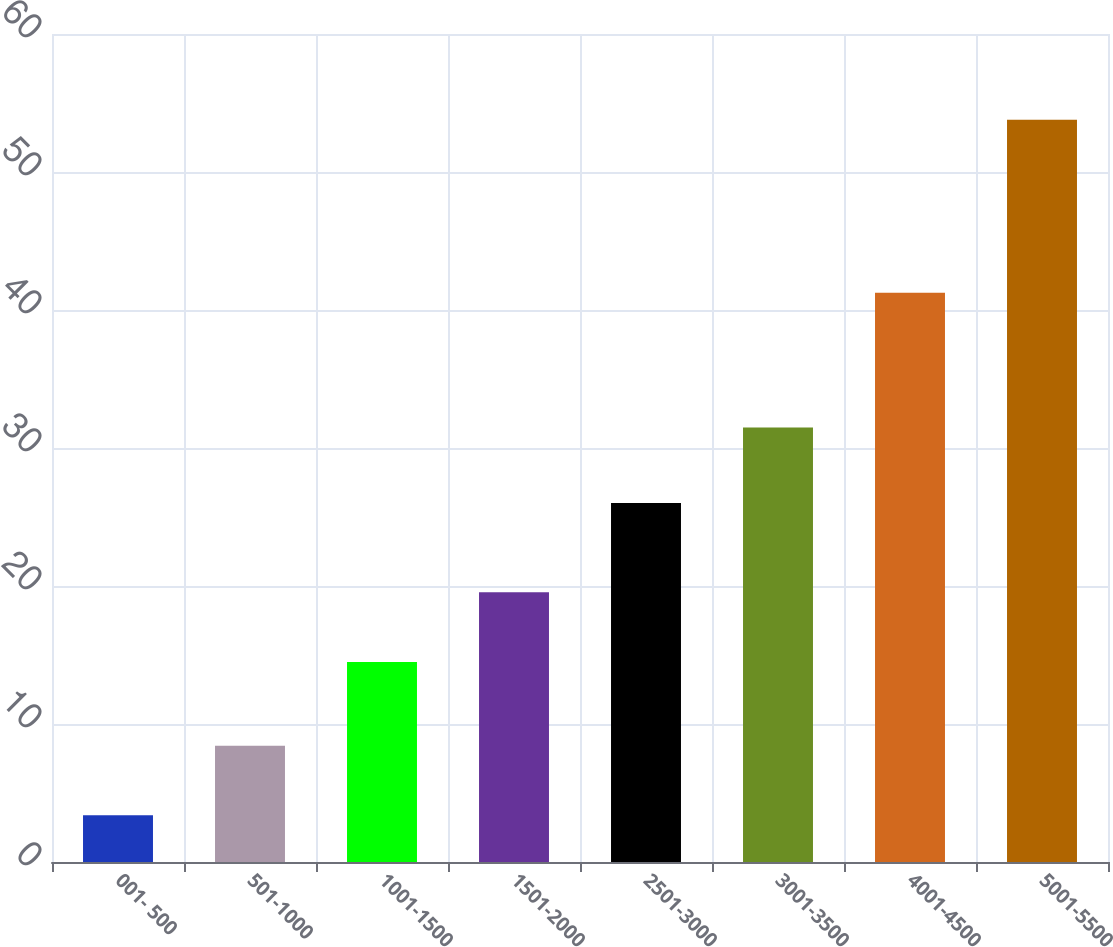<chart> <loc_0><loc_0><loc_500><loc_500><bar_chart><fcel>001- 500<fcel>501-1000<fcel>1001-1500<fcel>1501-2000<fcel>2501-3000<fcel>3001-3500<fcel>4001-4500<fcel>5001-5500<nl><fcel>3.38<fcel>8.42<fcel>14.5<fcel>19.54<fcel>26.01<fcel>31.49<fcel>41.25<fcel>53.78<nl></chart> 